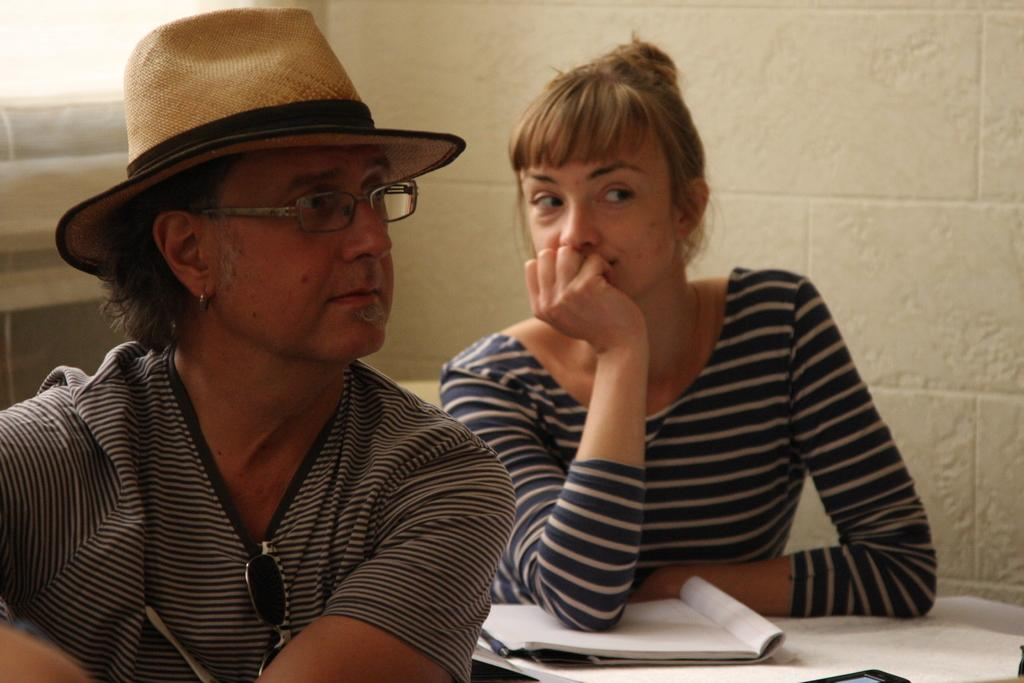How many people are present in the image? There are two people, a man and a woman, present in the image. What is the man wearing on his face? The man is wearing spectacles. What type of headwear is the man wearing? The man is wearing a cap. What objects can be seen in the image related to reading or learning? There are books in the image. What can be seen in the background of the image? There is a wall in the background of the image. What type of peace theory is being discussed in the image? There is no discussion or reference to any peace theory in the image; it features a man and a woman with books and a wall in the background. 